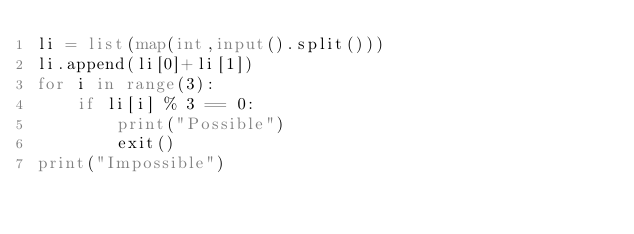Convert code to text. <code><loc_0><loc_0><loc_500><loc_500><_Python_>li = list(map(int,input().split()))
li.append(li[0]+li[1])
for i in range(3):
    if li[i] % 3 == 0:
        print("Possible")
        exit()
print("Impossible")
</code> 